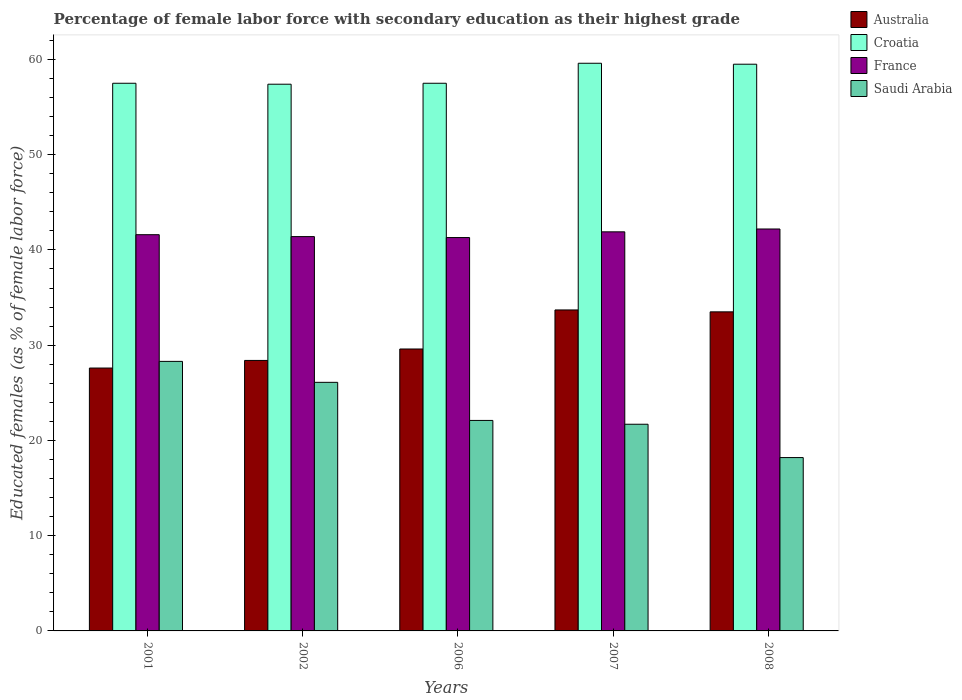How many different coloured bars are there?
Give a very brief answer. 4. Are the number of bars per tick equal to the number of legend labels?
Your answer should be very brief. Yes. How many bars are there on the 1st tick from the left?
Your answer should be compact. 4. How many bars are there on the 4th tick from the right?
Offer a very short reply. 4. What is the percentage of female labor force with secondary education in Australia in 2001?
Give a very brief answer. 27.6. Across all years, what is the maximum percentage of female labor force with secondary education in Croatia?
Make the answer very short. 59.6. Across all years, what is the minimum percentage of female labor force with secondary education in France?
Your answer should be very brief. 41.3. In which year was the percentage of female labor force with secondary education in Croatia minimum?
Keep it short and to the point. 2002. What is the total percentage of female labor force with secondary education in Saudi Arabia in the graph?
Keep it short and to the point. 116.4. What is the difference between the percentage of female labor force with secondary education in Saudi Arabia in 2008 and the percentage of female labor force with secondary education in Croatia in 2001?
Provide a short and direct response. -39.3. What is the average percentage of female labor force with secondary education in Australia per year?
Keep it short and to the point. 30.56. In the year 2001, what is the difference between the percentage of female labor force with secondary education in Saudi Arabia and percentage of female labor force with secondary education in Australia?
Keep it short and to the point. 0.7. What is the ratio of the percentage of female labor force with secondary education in Saudi Arabia in 2002 to that in 2007?
Offer a very short reply. 1.2. Is the percentage of female labor force with secondary education in France in 2001 less than that in 2008?
Offer a very short reply. Yes. What is the difference between the highest and the second highest percentage of female labor force with secondary education in Saudi Arabia?
Provide a short and direct response. 2.2. What is the difference between the highest and the lowest percentage of female labor force with secondary education in Croatia?
Keep it short and to the point. 2.2. In how many years, is the percentage of female labor force with secondary education in Australia greater than the average percentage of female labor force with secondary education in Australia taken over all years?
Your response must be concise. 2. Is the sum of the percentage of female labor force with secondary education in France in 2001 and 2002 greater than the maximum percentage of female labor force with secondary education in Saudi Arabia across all years?
Offer a terse response. Yes. What does the 1st bar from the right in 2008 represents?
Offer a terse response. Saudi Arabia. Are all the bars in the graph horizontal?
Offer a terse response. No. How many years are there in the graph?
Provide a succinct answer. 5. What is the difference between two consecutive major ticks on the Y-axis?
Offer a terse response. 10. Does the graph contain any zero values?
Your response must be concise. No. Where does the legend appear in the graph?
Ensure brevity in your answer.  Top right. How many legend labels are there?
Your answer should be compact. 4. How are the legend labels stacked?
Provide a short and direct response. Vertical. What is the title of the graph?
Provide a short and direct response. Percentage of female labor force with secondary education as their highest grade. Does "Armenia" appear as one of the legend labels in the graph?
Ensure brevity in your answer.  No. What is the label or title of the Y-axis?
Provide a succinct answer. Educated females (as % of female labor force). What is the Educated females (as % of female labor force) in Australia in 2001?
Offer a terse response. 27.6. What is the Educated females (as % of female labor force) of Croatia in 2001?
Provide a succinct answer. 57.5. What is the Educated females (as % of female labor force) of France in 2001?
Give a very brief answer. 41.6. What is the Educated females (as % of female labor force) of Saudi Arabia in 2001?
Your response must be concise. 28.3. What is the Educated females (as % of female labor force) of Australia in 2002?
Ensure brevity in your answer.  28.4. What is the Educated females (as % of female labor force) in Croatia in 2002?
Provide a short and direct response. 57.4. What is the Educated females (as % of female labor force) in France in 2002?
Give a very brief answer. 41.4. What is the Educated females (as % of female labor force) in Saudi Arabia in 2002?
Offer a terse response. 26.1. What is the Educated females (as % of female labor force) in Australia in 2006?
Ensure brevity in your answer.  29.6. What is the Educated females (as % of female labor force) of Croatia in 2006?
Keep it short and to the point. 57.5. What is the Educated females (as % of female labor force) of France in 2006?
Provide a short and direct response. 41.3. What is the Educated females (as % of female labor force) in Saudi Arabia in 2006?
Your response must be concise. 22.1. What is the Educated females (as % of female labor force) of Australia in 2007?
Offer a very short reply. 33.7. What is the Educated females (as % of female labor force) in Croatia in 2007?
Provide a succinct answer. 59.6. What is the Educated females (as % of female labor force) in France in 2007?
Provide a short and direct response. 41.9. What is the Educated females (as % of female labor force) of Saudi Arabia in 2007?
Make the answer very short. 21.7. What is the Educated females (as % of female labor force) of Australia in 2008?
Offer a very short reply. 33.5. What is the Educated females (as % of female labor force) of Croatia in 2008?
Your answer should be compact. 59.5. What is the Educated females (as % of female labor force) in France in 2008?
Offer a terse response. 42.2. What is the Educated females (as % of female labor force) in Saudi Arabia in 2008?
Keep it short and to the point. 18.2. Across all years, what is the maximum Educated females (as % of female labor force) of Australia?
Your response must be concise. 33.7. Across all years, what is the maximum Educated females (as % of female labor force) in Croatia?
Make the answer very short. 59.6. Across all years, what is the maximum Educated females (as % of female labor force) in France?
Provide a succinct answer. 42.2. Across all years, what is the maximum Educated females (as % of female labor force) of Saudi Arabia?
Make the answer very short. 28.3. Across all years, what is the minimum Educated females (as % of female labor force) of Australia?
Your answer should be compact. 27.6. Across all years, what is the minimum Educated females (as % of female labor force) of Croatia?
Offer a very short reply. 57.4. Across all years, what is the minimum Educated females (as % of female labor force) in France?
Offer a terse response. 41.3. Across all years, what is the minimum Educated females (as % of female labor force) in Saudi Arabia?
Give a very brief answer. 18.2. What is the total Educated females (as % of female labor force) of Australia in the graph?
Provide a succinct answer. 152.8. What is the total Educated females (as % of female labor force) of Croatia in the graph?
Your answer should be very brief. 291.5. What is the total Educated females (as % of female labor force) of France in the graph?
Your answer should be compact. 208.4. What is the total Educated females (as % of female labor force) in Saudi Arabia in the graph?
Give a very brief answer. 116.4. What is the difference between the Educated females (as % of female labor force) in Croatia in 2001 and that in 2002?
Keep it short and to the point. 0.1. What is the difference between the Educated females (as % of female labor force) in France in 2001 and that in 2002?
Offer a terse response. 0.2. What is the difference between the Educated females (as % of female labor force) in Saudi Arabia in 2001 and that in 2002?
Provide a short and direct response. 2.2. What is the difference between the Educated females (as % of female labor force) of Croatia in 2001 and that in 2006?
Your answer should be very brief. 0. What is the difference between the Educated females (as % of female labor force) of Croatia in 2001 and that in 2007?
Give a very brief answer. -2.1. What is the difference between the Educated females (as % of female labor force) in Saudi Arabia in 2001 and that in 2007?
Offer a very short reply. 6.6. What is the difference between the Educated females (as % of female labor force) in Saudi Arabia in 2001 and that in 2008?
Give a very brief answer. 10.1. What is the difference between the Educated females (as % of female labor force) in France in 2002 and that in 2006?
Provide a succinct answer. 0.1. What is the difference between the Educated females (as % of female labor force) of Croatia in 2002 and that in 2007?
Give a very brief answer. -2.2. What is the difference between the Educated females (as % of female labor force) in France in 2002 and that in 2007?
Offer a very short reply. -0.5. What is the difference between the Educated females (as % of female labor force) of Saudi Arabia in 2002 and that in 2007?
Offer a terse response. 4.4. What is the difference between the Educated females (as % of female labor force) in Croatia in 2002 and that in 2008?
Make the answer very short. -2.1. What is the difference between the Educated females (as % of female labor force) in France in 2002 and that in 2008?
Make the answer very short. -0.8. What is the difference between the Educated females (as % of female labor force) in Australia in 2006 and that in 2007?
Offer a terse response. -4.1. What is the difference between the Educated females (as % of female labor force) of Saudi Arabia in 2006 and that in 2007?
Give a very brief answer. 0.4. What is the difference between the Educated females (as % of female labor force) in Croatia in 2006 and that in 2008?
Give a very brief answer. -2. What is the difference between the Educated females (as % of female labor force) in Australia in 2001 and the Educated females (as % of female labor force) in Croatia in 2002?
Your response must be concise. -29.8. What is the difference between the Educated females (as % of female labor force) in Australia in 2001 and the Educated females (as % of female labor force) in Saudi Arabia in 2002?
Your response must be concise. 1.5. What is the difference between the Educated females (as % of female labor force) of Croatia in 2001 and the Educated females (as % of female labor force) of Saudi Arabia in 2002?
Keep it short and to the point. 31.4. What is the difference between the Educated females (as % of female labor force) of France in 2001 and the Educated females (as % of female labor force) of Saudi Arabia in 2002?
Offer a very short reply. 15.5. What is the difference between the Educated females (as % of female labor force) of Australia in 2001 and the Educated females (as % of female labor force) of Croatia in 2006?
Make the answer very short. -29.9. What is the difference between the Educated females (as % of female labor force) of Australia in 2001 and the Educated females (as % of female labor force) of France in 2006?
Offer a very short reply. -13.7. What is the difference between the Educated females (as % of female labor force) of Australia in 2001 and the Educated females (as % of female labor force) of Saudi Arabia in 2006?
Make the answer very short. 5.5. What is the difference between the Educated females (as % of female labor force) in Croatia in 2001 and the Educated females (as % of female labor force) in France in 2006?
Your response must be concise. 16.2. What is the difference between the Educated females (as % of female labor force) in Croatia in 2001 and the Educated females (as % of female labor force) in Saudi Arabia in 2006?
Offer a terse response. 35.4. What is the difference between the Educated females (as % of female labor force) of France in 2001 and the Educated females (as % of female labor force) of Saudi Arabia in 2006?
Give a very brief answer. 19.5. What is the difference between the Educated females (as % of female labor force) of Australia in 2001 and the Educated females (as % of female labor force) of Croatia in 2007?
Give a very brief answer. -32. What is the difference between the Educated females (as % of female labor force) in Australia in 2001 and the Educated females (as % of female labor force) in France in 2007?
Offer a very short reply. -14.3. What is the difference between the Educated females (as % of female labor force) in Australia in 2001 and the Educated females (as % of female labor force) in Saudi Arabia in 2007?
Your response must be concise. 5.9. What is the difference between the Educated females (as % of female labor force) of Croatia in 2001 and the Educated females (as % of female labor force) of Saudi Arabia in 2007?
Provide a succinct answer. 35.8. What is the difference between the Educated females (as % of female labor force) of Australia in 2001 and the Educated females (as % of female labor force) of Croatia in 2008?
Ensure brevity in your answer.  -31.9. What is the difference between the Educated females (as % of female labor force) of Australia in 2001 and the Educated females (as % of female labor force) of France in 2008?
Offer a terse response. -14.6. What is the difference between the Educated females (as % of female labor force) in Australia in 2001 and the Educated females (as % of female labor force) in Saudi Arabia in 2008?
Your answer should be compact. 9.4. What is the difference between the Educated females (as % of female labor force) of Croatia in 2001 and the Educated females (as % of female labor force) of Saudi Arabia in 2008?
Your response must be concise. 39.3. What is the difference between the Educated females (as % of female labor force) of France in 2001 and the Educated females (as % of female labor force) of Saudi Arabia in 2008?
Provide a short and direct response. 23.4. What is the difference between the Educated females (as % of female labor force) of Australia in 2002 and the Educated females (as % of female labor force) of Croatia in 2006?
Keep it short and to the point. -29.1. What is the difference between the Educated females (as % of female labor force) of Australia in 2002 and the Educated females (as % of female labor force) of France in 2006?
Offer a very short reply. -12.9. What is the difference between the Educated females (as % of female labor force) of Croatia in 2002 and the Educated females (as % of female labor force) of France in 2006?
Your answer should be very brief. 16.1. What is the difference between the Educated females (as % of female labor force) of Croatia in 2002 and the Educated females (as % of female labor force) of Saudi Arabia in 2006?
Ensure brevity in your answer.  35.3. What is the difference between the Educated females (as % of female labor force) of France in 2002 and the Educated females (as % of female labor force) of Saudi Arabia in 2006?
Keep it short and to the point. 19.3. What is the difference between the Educated females (as % of female labor force) of Australia in 2002 and the Educated females (as % of female labor force) of Croatia in 2007?
Offer a very short reply. -31.2. What is the difference between the Educated females (as % of female labor force) of Australia in 2002 and the Educated females (as % of female labor force) of France in 2007?
Ensure brevity in your answer.  -13.5. What is the difference between the Educated females (as % of female labor force) in Australia in 2002 and the Educated females (as % of female labor force) in Saudi Arabia in 2007?
Keep it short and to the point. 6.7. What is the difference between the Educated females (as % of female labor force) of Croatia in 2002 and the Educated females (as % of female labor force) of France in 2007?
Offer a terse response. 15.5. What is the difference between the Educated females (as % of female labor force) in Croatia in 2002 and the Educated females (as % of female labor force) in Saudi Arabia in 2007?
Provide a short and direct response. 35.7. What is the difference between the Educated females (as % of female labor force) of Australia in 2002 and the Educated females (as % of female labor force) of Croatia in 2008?
Your answer should be very brief. -31.1. What is the difference between the Educated females (as % of female labor force) in Australia in 2002 and the Educated females (as % of female labor force) in France in 2008?
Make the answer very short. -13.8. What is the difference between the Educated females (as % of female labor force) of Croatia in 2002 and the Educated females (as % of female labor force) of France in 2008?
Provide a short and direct response. 15.2. What is the difference between the Educated females (as % of female labor force) of Croatia in 2002 and the Educated females (as % of female labor force) of Saudi Arabia in 2008?
Make the answer very short. 39.2. What is the difference between the Educated females (as % of female labor force) in France in 2002 and the Educated females (as % of female labor force) in Saudi Arabia in 2008?
Offer a very short reply. 23.2. What is the difference between the Educated females (as % of female labor force) in Australia in 2006 and the Educated females (as % of female labor force) in Croatia in 2007?
Provide a succinct answer. -30. What is the difference between the Educated females (as % of female labor force) in Croatia in 2006 and the Educated females (as % of female labor force) in Saudi Arabia in 2007?
Give a very brief answer. 35.8. What is the difference between the Educated females (as % of female labor force) of France in 2006 and the Educated females (as % of female labor force) of Saudi Arabia in 2007?
Make the answer very short. 19.6. What is the difference between the Educated females (as % of female labor force) of Australia in 2006 and the Educated females (as % of female labor force) of Croatia in 2008?
Your answer should be compact. -29.9. What is the difference between the Educated females (as % of female labor force) in Australia in 2006 and the Educated females (as % of female labor force) in Saudi Arabia in 2008?
Ensure brevity in your answer.  11.4. What is the difference between the Educated females (as % of female labor force) in Croatia in 2006 and the Educated females (as % of female labor force) in France in 2008?
Ensure brevity in your answer.  15.3. What is the difference between the Educated females (as % of female labor force) of Croatia in 2006 and the Educated females (as % of female labor force) of Saudi Arabia in 2008?
Offer a terse response. 39.3. What is the difference between the Educated females (as % of female labor force) in France in 2006 and the Educated females (as % of female labor force) in Saudi Arabia in 2008?
Give a very brief answer. 23.1. What is the difference between the Educated females (as % of female labor force) of Australia in 2007 and the Educated females (as % of female labor force) of Croatia in 2008?
Offer a very short reply. -25.8. What is the difference between the Educated females (as % of female labor force) in Croatia in 2007 and the Educated females (as % of female labor force) in France in 2008?
Provide a succinct answer. 17.4. What is the difference between the Educated females (as % of female labor force) of Croatia in 2007 and the Educated females (as % of female labor force) of Saudi Arabia in 2008?
Offer a very short reply. 41.4. What is the difference between the Educated females (as % of female labor force) of France in 2007 and the Educated females (as % of female labor force) of Saudi Arabia in 2008?
Your response must be concise. 23.7. What is the average Educated females (as % of female labor force) in Australia per year?
Your answer should be very brief. 30.56. What is the average Educated females (as % of female labor force) of Croatia per year?
Provide a short and direct response. 58.3. What is the average Educated females (as % of female labor force) of France per year?
Offer a terse response. 41.68. What is the average Educated females (as % of female labor force) of Saudi Arabia per year?
Keep it short and to the point. 23.28. In the year 2001, what is the difference between the Educated females (as % of female labor force) in Australia and Educated females (as % of female labor force) in Croatia?
Provide a succinct answer. -29.9. In the year 2001, what is the difference between the Educated females (as % of female labor force) of Australia and Educated females (as % of female labor force) of Saudi Arabia?
Make the answer very short. -0.7. In the year 2001, what is the difference between the Educated females (as % of female labor force) in Croatia and Educated females (as % of female labor force) in France?
Your answer should be very brief. 15.9. In the year 2001, what is the difference between the Educated females (as % of female labor force) in Croatia and Educated females (as % of female labor force) in Saudi Arabia?
Ensure brevity in your answer.  29.2. In the year 2001, what is the difference between the Educated females (as % of female labor force) in France and Educated females (as % of female labor force) in Saudi Arabia?
Keep it short and to the point. 13.3. In the year 2002, what is the difference between the Educated females (as % of female labor force) in Australia and Educated females (as % of female labor force) in Saudi Arabia?
Keep it short and to the point. 2.3. In the year 2002, what is the difference between the Educated females (as % of female labor force) in Croatia and Educated females (as % of female labor force) in Saudi Arabia?
Your answer should be compact. 31.3. In the year 2002, what is the difference between the Educated females (as % of female labor force) of France and Educated females (as % of female labor force) of Saudi Arabia?
Your answer should be compact. 15.3. In the year 2006, what is the difference between the Educated females (as % of female labor force) in Australia and Educated females (as % of female labor force) in Croatia?
Your answer should be very brief. -27.9. In the year 2006, what is the difference between the Educated females (as % of female labor force) of Australia and Educated females (as % of female labor force) of France?
Offer a very short reply. -11.7. In the year 2006, what is the difference between the Educated females (as % of female labor force) of Croatia and Educated females (as % of female labor force) of France?
Your response must be concise. 16.2. In the year 2006, what is the difference between the Educated females (as % of female labor force) of Croatia and Educated females (as % of female labor force) of Saudi Arabia?
Your answer should be compact. 35.4. In the year 2006, what is the difference between the Educated females (as % of female labor force) of France and Educated females (as % of female labor force) of Saudi Arabia?
Give a very brief answer. 19.2. In the year 2007, what is the difference between the Educated females (as % of female labor force) in Australia and Educated females (as % of female labor force) in Croatia?
Provide a short and direct response. -25.9. In the year 2007, what is the difference between the Educated females (as % of female labor force) in Croatia and Educated females (as % of female labor force) in France?
Provide a succinct answer. 17.7. In the year 2007, what is the difference between the Educated females (as % of female labor force) in Croatia and Educated females (as % of female labor force) in Saudi Arabia?
Your response must be concise. 37.9. In the year 2007, what is the difference between the Educated females (as % of female labor force) of France and Educated females (as % of female labor force) of Saudi Arabia?
Your response must be concise. 20.2. In the year 2008, what is the difference between the Educated females (as % of female labor force) in Croatia and Educated females (as % of female labor force) in France?
Your answer should be compact. 17.3. In the year 2008, what is the difference between the Educated females (as % of female labor force) in Croatia and Educated females (as % of female labor force) in Saudi Arabia?
Your response must be concise. 41.3. What is the ratio of the Educated females (as % of female labor force) of Australia in 2001 to that in 2002?
Your answer should be compact. 0.97. What is the ratio of the Educated females (as % of female labor force) in Saudi Arabia in 2001 to that in 2002?
Ensure brevity in your answer.  1.08. What is the ratio of the Educated females (as % of female labor force) in Australia in 2001 to that in 2006?
Your answer should be compact. 0.93. What is the ratio of the Educated females (as % of female labor force) of France in 2001 to that in 2006?
Provide a succinct answer. 1.01. What is the ratio of the Educated females (as % of female labor force) of Saudi Arabia in 2001 to that in 2006?
Offer a terse response. 1.28. What is the ratio of the Educated females (as % of female labor force) of Australia in 2001 to that in 2007?
Provide a succinct answer. 0.82. What is the ratio of the Educated females (as % of female labor force) of Croatia in 2001 to that in 2007?
Make the answer very short. 0.96. What is the ratio of the Educated females (as % of female labor force) in France in 2001 to that in 2007?
Provide a short and direct response. 0.99. What is the ratio of the Educated females (as % of female labor force) in Saudi Arabia in 2001 to that in 2007?
Your answer should be compact. 1.3. What is the ratio of the Educated females (as % of female labor force) in Australia in 2001 to that in 2008?
Make the answer very short. 0.82. What is the ratio of the Educated females (as % of female labor force) in Croatia in 2001 to that in 2008?
Keep it short and to the point. 0.97. What is the ratio of the Educated females (as % of female labor force) of France in 2001 to that in 2008?
Your answer should be very brief. 0.99. What is the ratio of the Educated females (as % of female labor force) in Saudi Arabia in 2001 to that in 2008?
Offer a very short reply. 1.55. What is the ratio of the Educated females (as % of female labor force) of Australia in 2002 to that in 2006?
Your answer should be very brief. 0.96. What is the ratio of the Educated females (as % of female labor force) of Croatia in 2002 to that in 2006?
Keep it short and to the point. 1. What is the ratio of the Educated females (as % of female labor force) of France in 2002 to that in 2006?
Offer a terse response. 1. What is the ratio of the Educated females (as % of female labor force) of Saudi Arabia in 2002 to that in 2006?
Your answer should be very brief. 1.18. What is the ratio of the Educated females (as % of female labor force) of Australia in 2002 to that in 2007?
Ensure brevity in your answer.  0.84. What is the ratio of the Educated females (as % of female labor force) in Croatia in 2002 to that in 2007?
Keep it short and to the point. 0.96. What is the ratio of the Educated females (as % of female labor force) of Saudi Arabia in 2002 to that in 2007?
Provide a succinct answer. 1.2. What is the ratio of the Educated females (as % of female labor force) in Australia in 2002 to that in 2008?
Ensure brevity in your answer.  0.85. What is the ratio of the Educated females (as % of female labor force) in Croatia in 2002 to that in 2008?
Give a very brief answer. 0.96. What is the ratio of the Educated females (as % of female labor force) in Saudi Arabia in 2002 to that in 2008?
Your response must be concise. 1.43. What is the ratio of the Educated females (as % of female labor force) of Australia in 2006 to that in 2007?
Offer a very short reply. 0.88. What is the ratio of the Educated females (as % of female labor force) in Croatia in 2006 to that in 2007?
Your response must be concise. 0.96. What is the ratio of the Educated females (as % of female labor force) in France in 2006 to that in 2007?
Your answer should be very brief. 0.99. What is the ratio of the Educated females (as % of female labor force) of Saudi Arabia in 2006 to that in 2007?
Give a very brief answer. 1.02. What is the ratio of the Educated females (as % of female labor force) of Australia in 2006 to that in 2008?
Offer a very short reply. 0.88. What is the ratio of the Educated females (as % of female labor force) in Croatia in 2006 to that in 2008?
Offer a terse response. 0.97. What is the ratio of the Educated females (as % of female labor force) of France in 2006 to that in 2008?
Offer a terse response. 0.98. What is the ratio of the Educated females (as % of female labor force) of Saudi Arabia in 2006 to that in 2008?
Provide a short and direct response. 1.21. What is the ratio of the Educated females (as % of female labor force) in Australia in 2007 to that in 2008?
Your response must be concise. 1.01. What is the ratio of the Educated females (as % of female labor force) of Saudi Arabia in 2007 to that in 2008?
Keep it short and to the point. 1.19. What is the difference between the highest and the second highest Educated females (as % of female labor force) in Australia?
Provide a succinct answer. 0.2. What is the difference between the highest and the second highest Educated females (as % of female labor force) of France?
Your answer should be compact. 0.3. What is the difference between the highest and the second highest Educated females (as % of female labor force) of Saudi Arabia?
Your answer should be compact. 2.2. What is the difference between the highest and the lowest Educated females (as % of female labor force) in Croatia?
Keep it short and to the point. 2.2. 